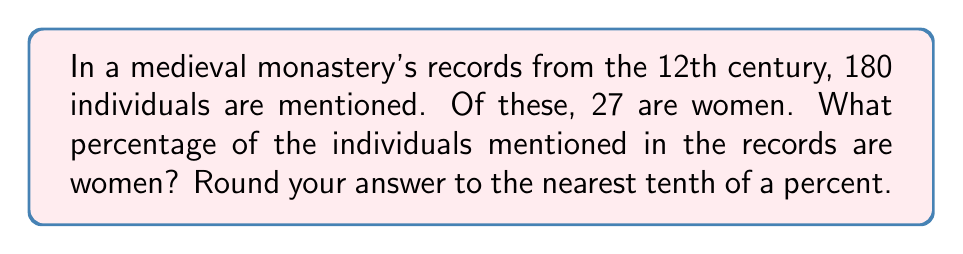Teach me how to tackle this problem. To solve this problem, we need to calculate the percentage of women mentioned in the records. Let's break it down step by step:

1. Identify the given information:
   - Total number of individuals mentioned: 180
   - Number of women mentioned: 27

2. Set up the percentage formula:
   $$ \text{Percentage} = \frac{\text{Part}}{\text{Whole}} \times 100\% $$

3. Plug in the values:
   $$ \text{Percentage of women} = \frac{27}{180} \times 100\% $$

4. Perform the division:
   $$ \frac{27}{180} = 0.15 $$

5. Multiply by 100 to convert to a percentage:
   $$ 0.15 \times 100\% = 15\% $$

6. Round to the nearest tenth of a percent:
   15% is already rounded to the nearest tenth, so no further rounding is necessary.

Therefore, the percentage of women mentioned in the medieval monastery's records is 15.0%.
Answer: 15.0% 